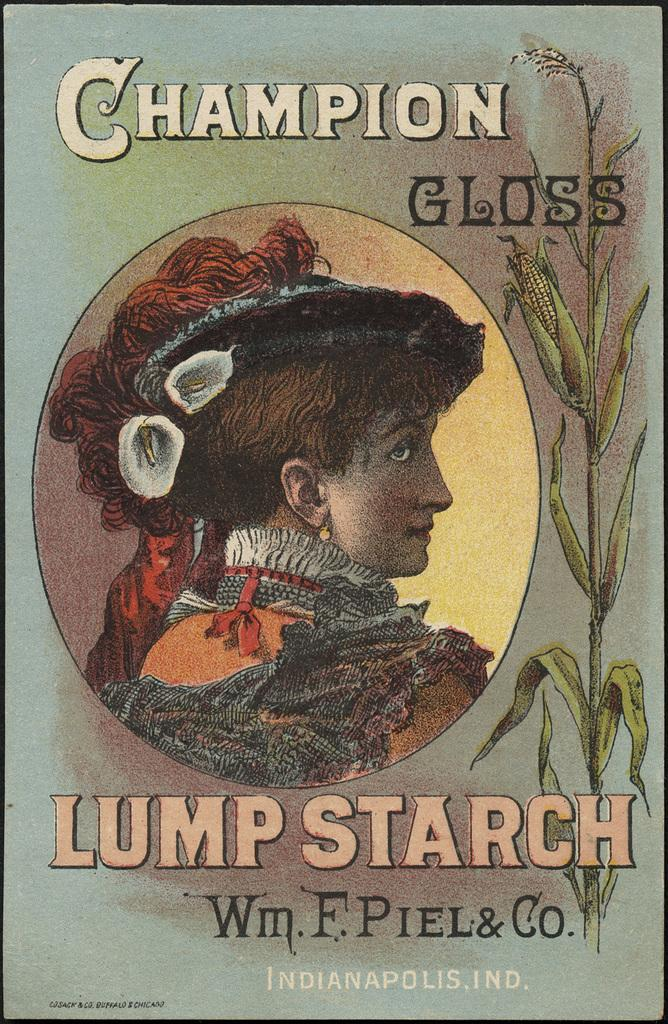<image>
Relay a brief, clear account of the picture shown. A box of Champion Gloss lump starch hails from Indianapolis, Indiana. 